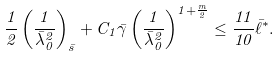Convert formula to latex. <formula><loc_0><loc_0><loc_500><loc_500>\frac { 1 } { 2 } \left ( \frac { 1 } { \bar { \lambda } _ { 0 } ^ { 2 } } \right ) _ { \bar { s } } + C _ { 1 } \bar { \gamma } \left ( \frac { 1 } { \bar { \lambda } _ { 0 } ^ { 2 } } \right ) ^ { 1 + \frac { m } { 2 } } \leq \frac { 1 1 } { 1 0 } \bar { \ell } ^ { * } .</formula> 